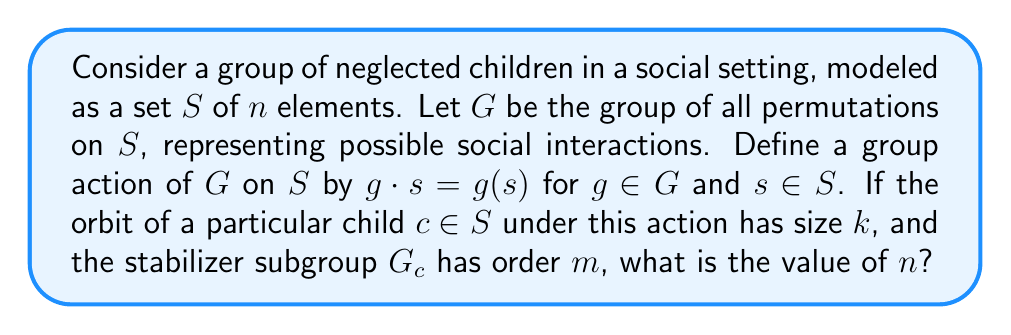Could you help me with this problem? To solve this problem, we'll use the Orbit-Stabilizer Theorem from group theory and apply it to the context of social interactions among neglected children.

1) The Orbit-Stabilizer Theorem states that for a group $G$ acting on a set $S$, and for any element $s \in S$:

   $$|G| = |Orbit(s)| \cdot |Stab(s)|$$

   where $|G|$ is the order of the group, $|Orbit(s)|$ is the size of the orbit of $s$, and $|Stab(s)|$ is the order of the stabilizer of $s$.

2) In this case, $G$ is the group of all permutations on $S$, so $|G| = n!$ where $n$ is the number of elements in $S$ (i.e., the number of children).

3) We're given that the orbit of child $c$ has size $k$, so $|Orbit(c)| = k$.

4) We're also given that the stabilizer subgroup $G_c$ has order $m$, so $|Stab(c)| = m$.

5) Applying the Orbit-Stabilizer Theorem:

   $$n! = k \cdot m$$

6) This equation relates $n$ (the total number of children) to $k$ (the size of the orbit) and $m$ (the order of the stabilizer).

7) To solve for $n$, we need to find the smallest positive integer that satisfies this equation.
Answer: The value of $n$ is the smallest positive integer that satisfies the equation $n! = k \cdot m$. 